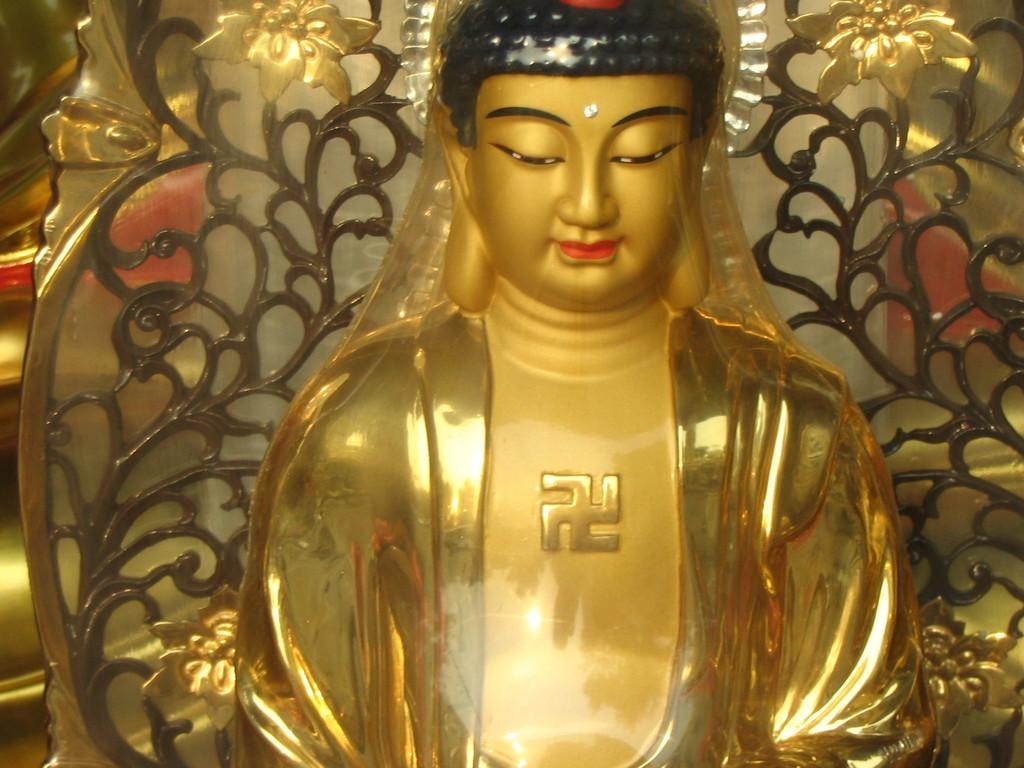What is the main subject of the image? There is a statue in the image. How many seats are available for the hand-carved trees in the image? There are no seats or hand-carved trees present in the image; it features a statue. 